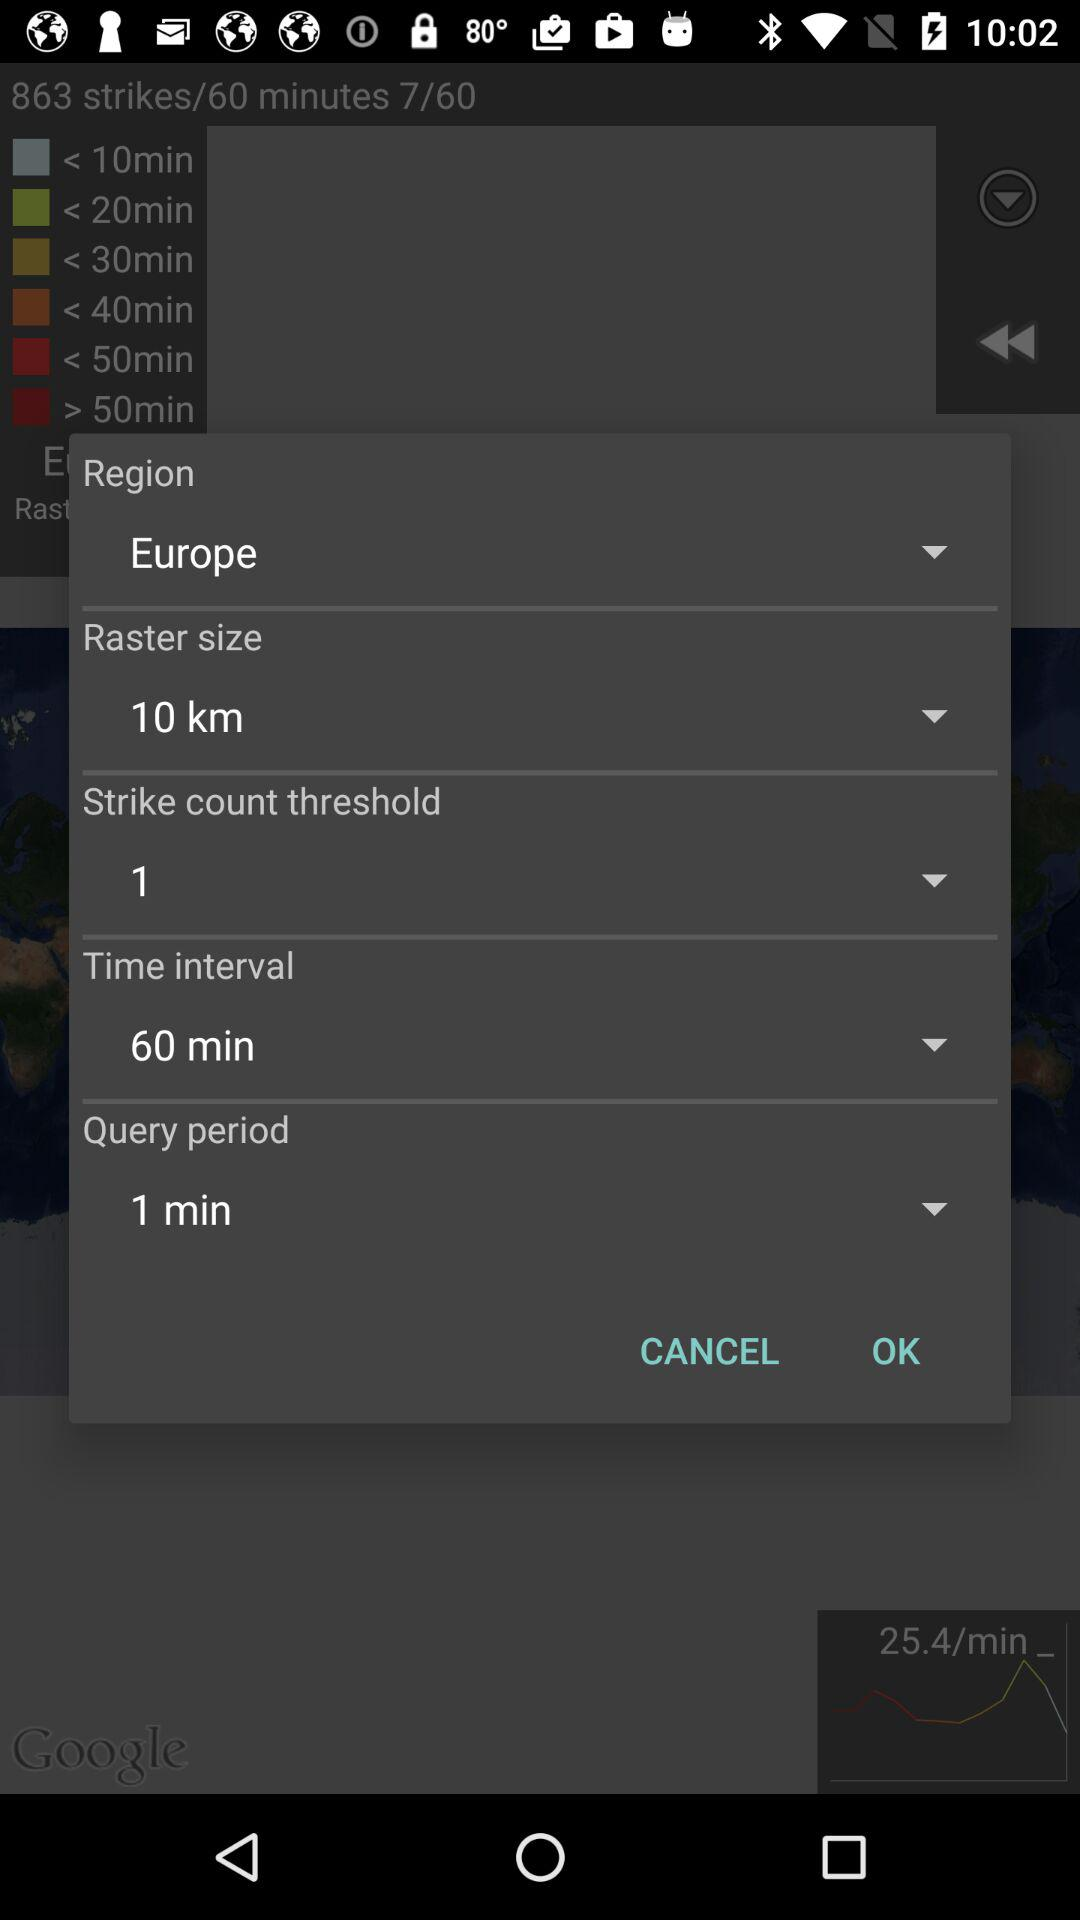What is the raster size? The raster size is 10 km. 